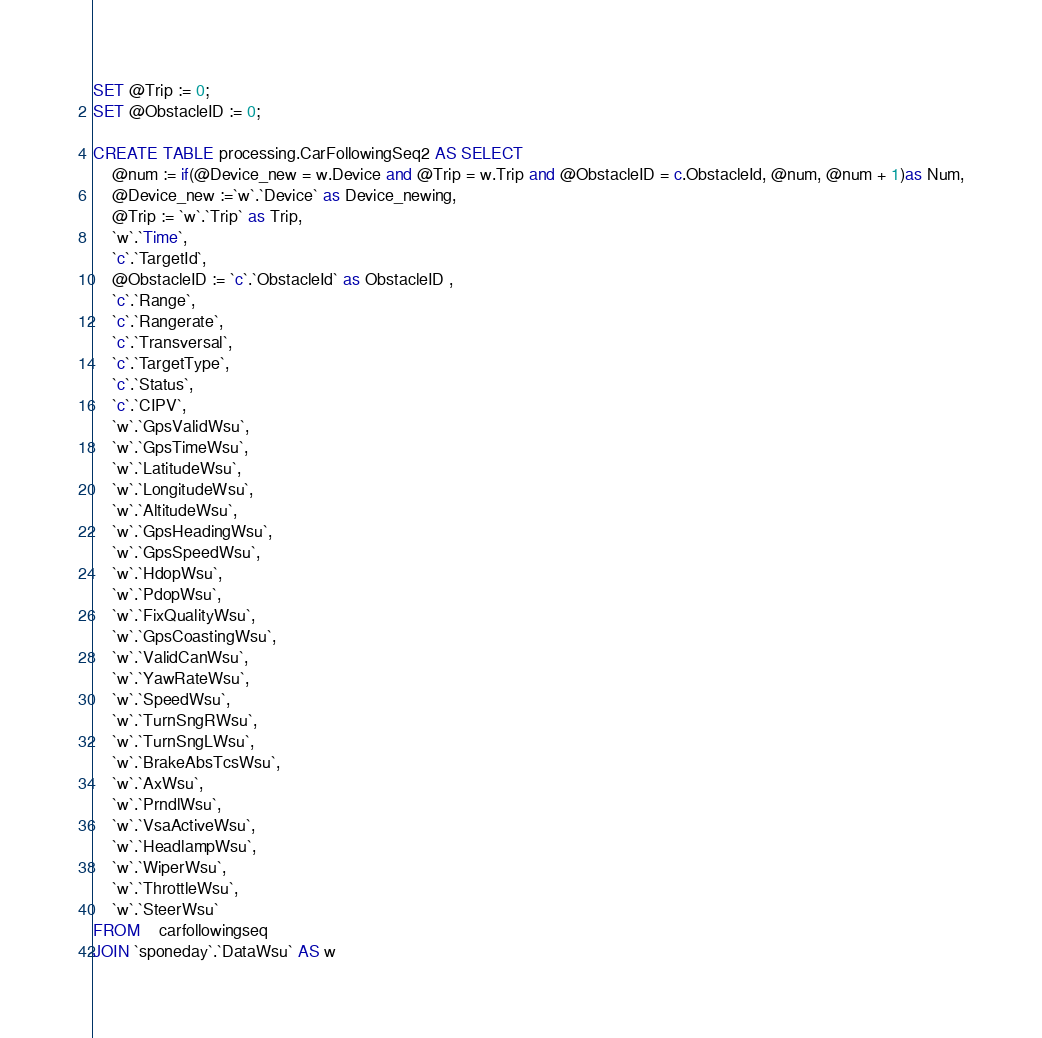<code> <loc_0><loc_0><loc_500><loc_500><_SQL_>SET @Trip := 0;
SET @ObstacleID := 0;

CREATE TABLE processing.CarFollowingSeq2 AS SELECT 
	@num := if(@Device_new = w.Device and @Trip = w.Trip and @ObstacleID = c.ObstacleId, @num, @num + 1)as Num,
	@Device_new :=`w`.`Device` as Device_newing,
    @Trip := `w`.`Trip` as Trip,
    `w`.`Time`,
    `c`.`TargetId`,
    @ObstacleID := `c`.`ObstacleId` as ObstacleID ,
    `c`.`Range`,
    `c`.`Rangerate`,
    `c`.`Transversal`,
    `c`.`TargetType`,
    `c`.`Status`,
    `c`.`CIPV`,
    `w`.`GpsValidWsu`,
    `w`.`GpsTimeWsu`,
    `w`.`LatitudeWsu`,
    `w`.`LongitudeWsu`,
    `w`.`AltitudeWsu`,
    `w`.`GpsHeadingWsu`,
    `w`.`GpsSpeedWsu`,
    `w`.`HdopWsu`,
    `w`.`PdopWsu`,
    `w`.`FixQualityWsu`,
    `w`.`GpsCoastingWsu`,
    `w`.`ValidCanWsu`,
    `w`.`YawRateWsu`,
    `w`.`SpeedWsu`,
    `w`.`TurnSngRWsu`,
    `w`.`TurnSngLWsu`,
    `w`.`BrakeAbsTcsWsu`,
    `w`.`AxWsu`,
    `w`.`PrndlWsu`,
    `w`.`VsaActiveWsu`,
    `w`.`HeadlampWsu`,
    `w`.`WiperWsu`,
    `w`.`ThrottleWsu`,
    `w`.`SteerWsu`
FROM    carfollowingseq 
JOIN `sponeday`.`DataWsu` AS w </code> 